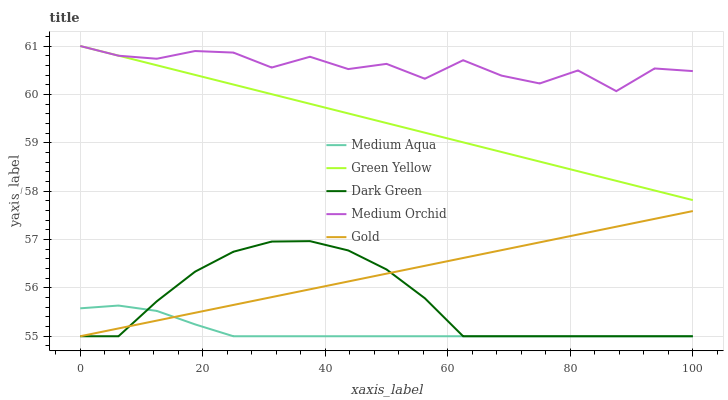Does Medium Aqua have the minimum area under the curve?
Answer yes or no. Yes. Does Medium Orchid have the maximum area under the curve?
Answer yes or no. Yes. Does Green Yellow have the minimum area under the curve?
Answer yes or no. No. Does Green Yellow have the maximum area under the curve?
Answer yes or no. No. Is Gold the smoothest?
Answer yes or no. Yes. Is Medium Orchid the roughest?
Answer yes or no. Yes. Is Green Yellow the smoothest?
Answer yes or no. No. Is Green Yellow the roughest?
Answer yes or no. No. Does Medium Aqua have the lowest value?
Answer yes or no. Yes. Does Green Yellow have the lowest value?
Answer yes or no. No. Does Green Yellow have the highest value?
Answer yes or no. Yes. Does Medium Aqua have the highest value?
Answer yes or no. No. Is Medium Aqua less than Green Yellow?
Answer yes or no. Yes. Is Medium Orchid greater than Medium Aqua?
Answer yes or no. Yes. Does Dark Green intersect Medium Aqua?
Answer yes or no. Yes. Is Dark Green less than Medium Aqua?
Answer yes or no. No. Is Dark Green greater than Medium Aqua?
Answer yes or no. No. Does Medium Aqua intersect Green Yellow?
Answer yes or no. No. 